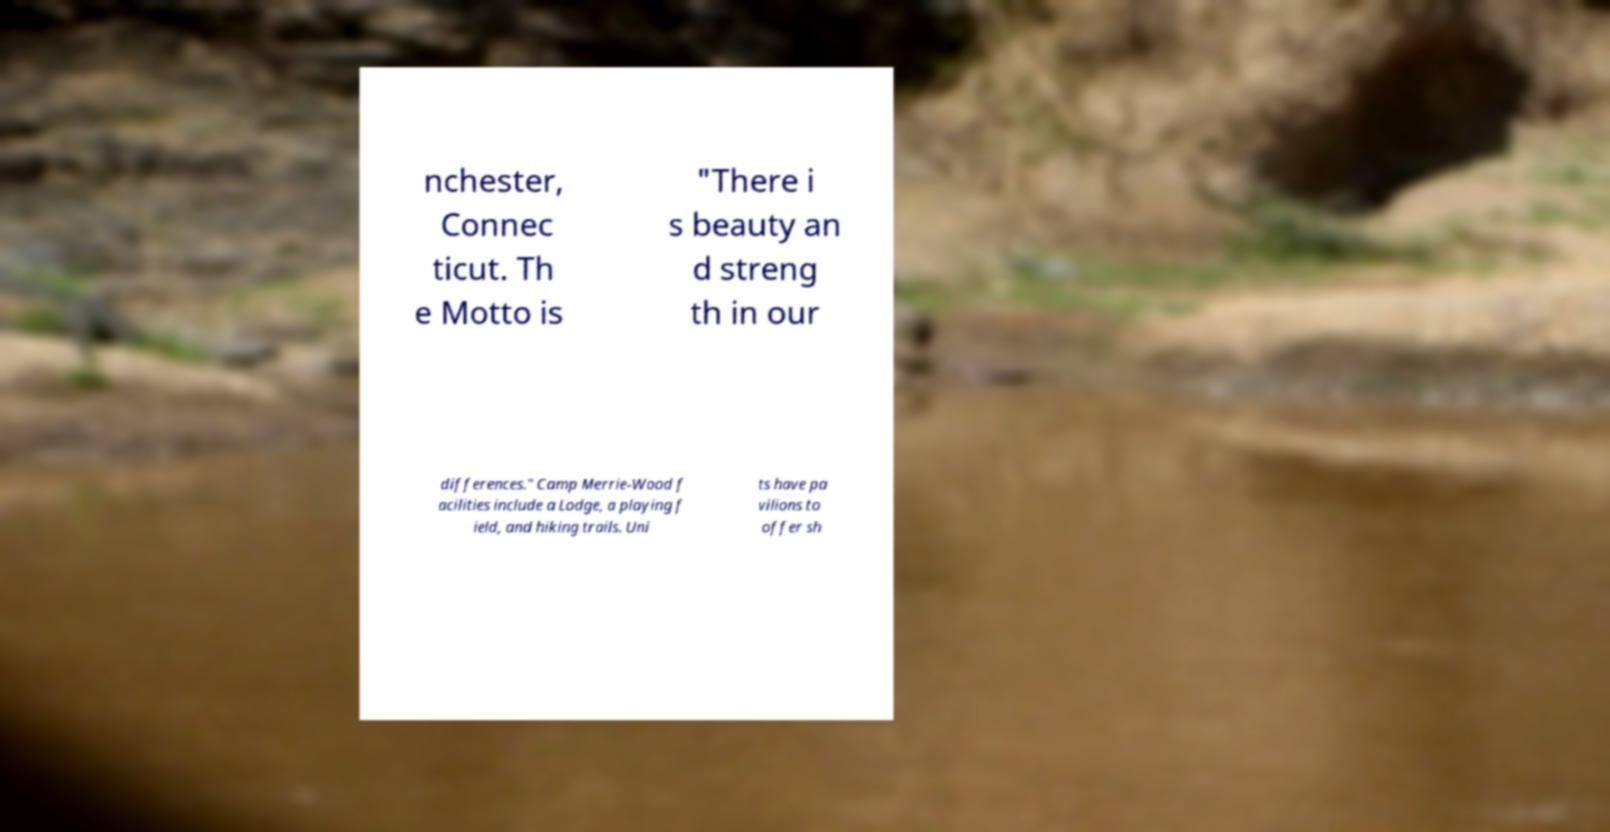Please read and relay the text visible in this image. What does it say? nchester, Connec ticut. Th e Motto is "There i s beauty an d streng th in our differences." Camp Merrie-Wood f acilities include a Lodge, a playing f ield, and hiking trails. Uni ts have pa vilions to offer sh 